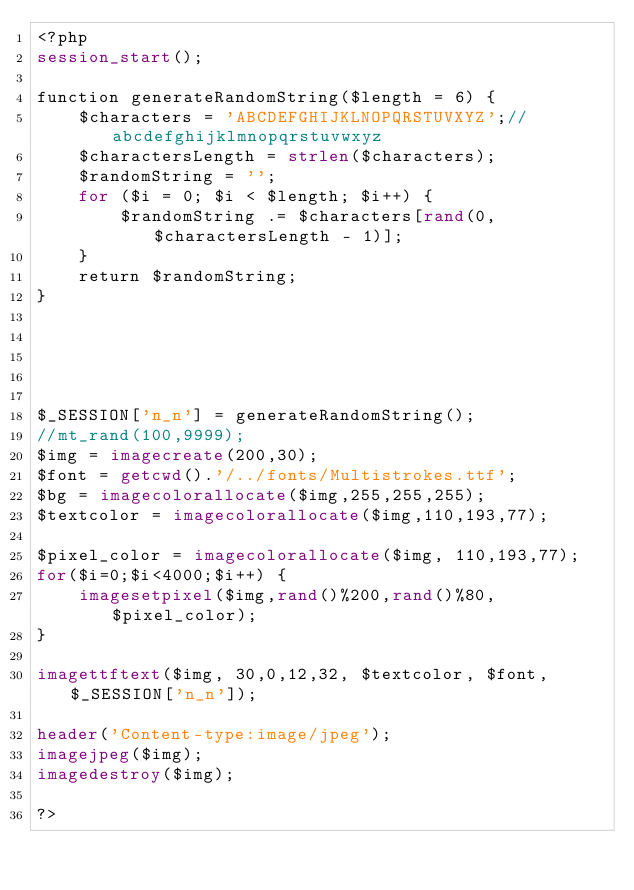Convert code to text. <code><loc_0><loc_0><loc_500><loc_500><_PHP_><?php
session_start();

function generateRandomString($length = 6) {
    $characters = 'ABCDEFGHIJKLNOPQRSTUVXYZ';//abcdefghijklmnopqrstuvwxyz
    $charactersLength = strlen($characters);
    $randomString = '';
    for ($i = 0; $i < $length; $i++) {
        $randomString .= $characters[rand(0, $charactersLength - 1)];
    }
    return $randomString;
}





$_SESSION['n_n'] = generateRandomString();
//mt_rand(100,9999);
$img = imagecreate(200,30);
$font = getcwd().'/../fonts/Multistrokes.ttf';
$bg = imagecolorallocate($img,255,255,255);
$textcolor = imagecolorallocate($img,110,193,77);

$pixel_color = imagecolorallocate($img, 110,193,77);
for($i=0;$i<4000;$i++) {
    imagesetpixel($img,rand()%200,rand()%80,$pixel_color);
}  

imagettftext($img, 30,0,12,32, $textcolor, $font,$_SESSION['n_n']);

header('Content-type:image/jpeg');
imagejpeg($img);
imagedestroy($img);

?></code> 